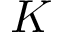Convert formula to latex. <formula><loc_0><loc_0><loc_500><loc_500>K</formula> 